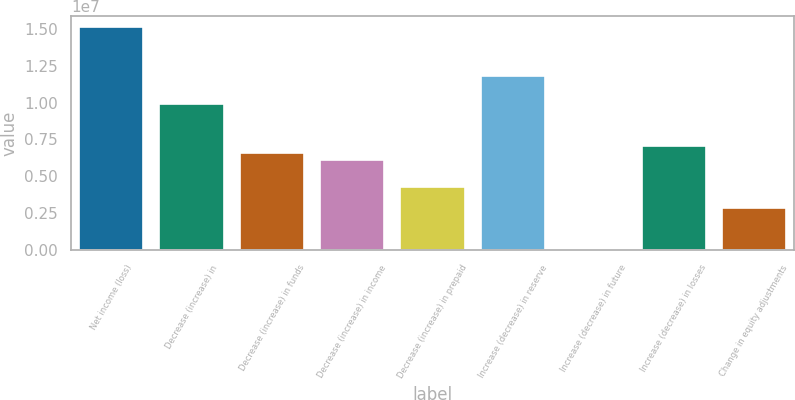Convert chart to OTSL. <chart><loc_0><loc_0><loc_500><loc_500><bar_chart><fcel>Net income (loss)<fcel>Decrease (increase) in<fcel>Decrease (increase) in funds<fcel>Decrease (increase) in income<fcel>Decrease (increase) in prepaid<fcel>Increase (decrease) in reserve<fcel>Increase (decrease) in future<fcel>Increase (decrease) in losses<fcel>Change in equity adjustments<nl><fcel>1.50966e+07<fcel>9.90744e+06<fcel>6.60526e+06<fcel>6.13352e+06<fcel>4.24656e+06<fcel>1.17944e+07<fcel>910<fcel>7.077e+06<fcel>2.83135e+06<nl></chart> 